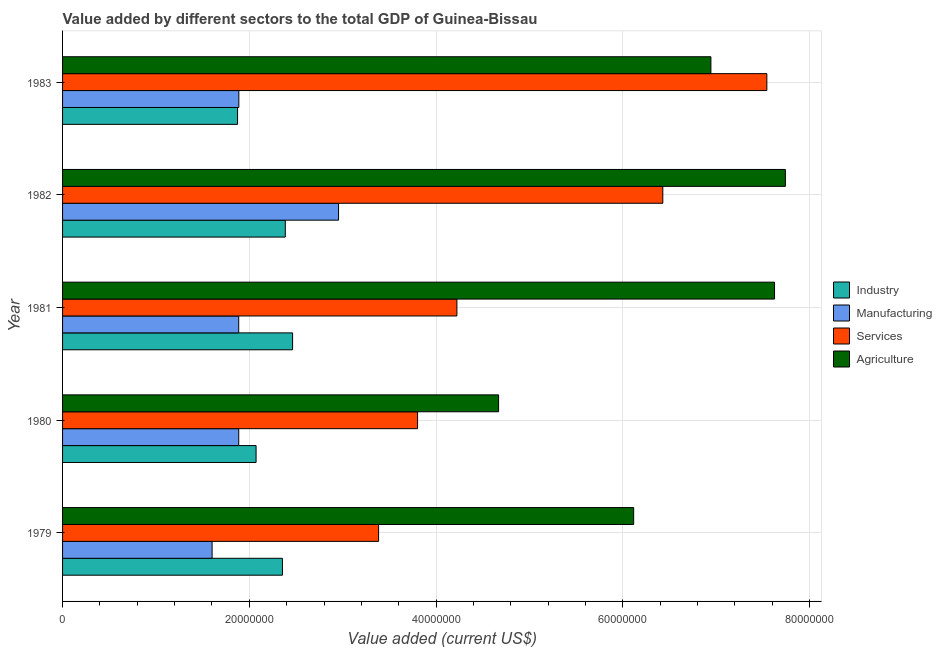How many groups of bars are there?
Your answer should be very brief. 5. Are the number of bars per tick equal to the number of legend labels?
Give a very brief answer. Yes. How many bars are there on the 5th tick from the top?
Your response must be concise. 4. What is the label of the 3rd group of bars from the top?
Your response must be concise. 1981. In how many cases, is the number of bars for a given year not equal to the number of legend labels?
Make the answer very short. 0. What is the value added by manufacturing sector in 1982?
Give a very brief answer. 2.96e+07. Across all years, what is the maximum value added by industrial sector?
Make the answer very short. 2.46e+07. Across all years, what is the minimum value added by services sector?
Provide a succinct answer. 3.38e+07. What is the total value added by services sector in the graph?
Keep it short and to the point. 2.54e+08. What is the difference between the value added by industrial sector in 1982 and that in 1983?
Keep it short and to the point. 5.11e+06. What is the difference between the value added by industrial sector in 1979 and the value added by services sector in 1983?
Your answer should be compact. -5.19e+07. What is the average value added by agricultural sector per year?
Give a very brief answer. 6.62e+07. In the year 1982, what is the difference between the value added by manufacturing sector and value added by industrial sector?
Ensure brevity in your answer.  5.70e+06. What is the ratio of the value added by manufacturing sector in 1979 to that in 1982?
Give a very brief answer. 0.54. Is the difference between the value added by services sector in 1980 and 1981 greater than the difference between the value added by industrial sector in 1980 and 1981?
Ensure brevity in your answer.  No. What is the difference between the highest and the second highest value added by agricultural sector?
Offer a terse response. 1.16e+06. What is the difference between the highest and the lowest value added by agricultural sector?
Your answer should be very brief. 3.07e+07. Is it the case that in every year, the sum of the value added by agricultural sector and value added by manufacturing sector is greater than the sum of value added by industrial sector and value added by services sector?
Offer a terse response. Yes. What does the 4th bar from the top in 1980 represents?
Your answer should be compact. Industry. What does the 2nd bar from the bottom in 1982 represents?
Your answer should be very brief. Manufacturing. Is it the case that in every year, the sum of the value added by industrial sector and value added by manufacturing sector is greater than the value added by services sector?
Ensure brevity in your answer.  No. How many bars are there?
Your answer should be compact. 20. Are all the bars in the graph horizontal?
Keep it short and to the point. Yes. How many years are there in the graph?
Provide a short and direct response. 5. What is the difference between two consecutive major ticks on the X-axis?
Keep it short and to the point. 2.00e+07. Does the graph contain grids?
Your answer should be very brief. Yes. How many legend labels are there?
Offer a very short reply. 4. How are the legend labels stacked?
Offer a terse response. Vertical. What is the title of the graph?
Your answer should be compact. Value added by different sectors to the total GDP of Guinea-Bissau. What is the label or title of the X-axis?
Provide a short and direct response. Value added (current US$). What is the label or title of the Y-axis?
Your answer should be compact. Year. What is the Value added (current US$) of Industry in 1979?
Your response must be concise. 2.35e+07. What is the Value added (current US$) in Manufacturing in 1979?
Offer a terse response. 1.60e+07. What is the Value added (current US$) in Services in 1979?
Your response must be concise. 3.38e+07. What is the Value added (current US$) of Agriculture in 1979?
Your answer should be compact. 6.12e+07. What is the Value added (current US$) of Industry in 1980?
Give a very brief answer. 2.07e+07. What is the Value added (current US$) in Manufacturing in 1980?
Provide a short and direct response. 1.89e+07. What is the Value added (current US$) in Services in 1980?
Give a very brief answer. 3.80e+07. What is the Value added (current US$) of Agriculture in 1980?
Make the answer very short. 4.67e+07. What is the Value added (current US$) in Industry in 1981?
Ensure brevity in your answer.  2.46e+07. What is the Value added (current US$) in Manufacturing in 1981?
Your answer should be very brief. 1.89e+07. What is the Value added (current US$) in Services in 1981?
Provide a short and direct response. 4.22e+07. What is the Value added (current US$) in Agriculture in 1981?
Your response must be concise. 7.62e+07. What is the Value added (current US$) of Industry in 1982?
Your answer should be compact. 2.39e+07. What is the Value added (current US$) of Manufacturing in 1982?
Give a very brief answer. 2.96e+07. What is the Value added (current US$) of Services in 1982?
Your answer should be compact. 6.43e+07. What is the Value added (current US$) of Agriculture in 1982?
Offer a very short reply. 7.74e+07. What is the Value added (current US$) in Industry in 1983?
Your answer should be very brief. 1.87e+07. What is the Value added (current US$) in Manufacturing in 1983?
Offer a terse response. 1.89e+07. What is the Value added (current US$) of Services in 1983?
Provide a succinct answer. 7.54e+07. What is the Value added (current US$) of Agriculture in 1983?
Provide a succinct answer. 6.94e+07. Across all years, what is the maximum Value added (current US$) of Industry?
Give a very brief answer. 2.46e+07. Across all years, what is the maximum Value added (current US$) of Manufacturing?
Provide a short and direct response. 2.96e+07. Across all years, what is the maximum Value added (current US$) of Services?
Keep it short and to the point. 7.54e+07. Across all years, what is the maximum Value added (current US$) in Agriculture?
Ensure brevity in your answer.  7.74e+07. Across all years, what is the minimum Value added (current US$) of Industry?
Give a very brief answer. 1.87e+07. Across all years, what is the minimum Value added (current US$) in Manufacturing?
Your answer should be very brief. 1.60e+07. Across all years, what is the minimum Value added (current US$) of Services?
Your response must be concise. 3.38e+07. Across all years, what is the minimum Value added (current US$) in Agriculture?
Give a very brief answer. 4.67e+07. What is the total Value added (current US$) in Industry in the graph?
Give a very brief answer. 1.11e+08. What is the total Value added (current US$) in Manufacturing in the graph?
Ensure brevity in your answer.  1.02e+08. What is the total Value added (current US$) of Services in the graph?
Keep it short and to the point. 2.54e+08. What is the total Value added (current US$) of Agriculture in the graph?
Offer a very short reply. 3.31e+08. What is the difference between the Value added (current US$) of Industry in 1979 and that in 1980?
Provide a succinct answer. 2.82e+06. What is the difference between the Value added (current US$) of Manufacturing in 1979 and that in 1980?
Give a very brief answer. -2.85e+06. What is the difference between the Value added (current US$) in Services in 1979 and that in 1980?
Provide a short and direct response. -4.17e+06. What is the difference between the Value added (current US$) in Agriculture in 1979 and that in 1980?
Make the answer very short. 1.45e+07. What is the difference between the Value added (current US$) of Industry in 1979 and that in 1981?
Keep it short and to the point. -1.09e+06. What is the difference between the Value added (current US$) of Manufacturing in 1979 and that in 1981?
Your answer should be compact. -2.85e+06. What is the difference between the Value added (current US$) in Services in 1979 and that in 1981?
Provide a succinct answer. -8.39e+06. What is the difference between the Value added (current US$) of Agriculture in 1979 and that in 1981?
Make the answer very short. -1.51e+07. What is the difference between the Value added (current US$) of Industry in 1979 and that in 1982?
Offer a terse response. -3.05e+05. What is the difference between the Value added (current US$) of Manufacturing in 1979 and that in 1982?
Your answer should be compact. -1.35e+07. What is the difference between the Value added (current US$) in Services in 1979 and that in 1982?
Offer a very short reply. -3.04e+07. What is the difference between the Value added (current US$) of Agriculture in 1979 and that in 1982?
Your answer should be compact. -1.62e+07. What is the difference between the Value added (current US$) in Industry in 1979 and that in 1983?
Provide a succinct answer. 4.81e+06. What is the difference between the Value added (current US$) of Manufacturing in 1979 and that in 1983?
Give a very brief answer. -2.86e+06. What is the difference between the Value added (current US$) in Services in 1979 and that in 1983?
Your response must be concise. -4.16e+07. What is the difference between the Value added (current US$) of Agriculture in 1979 and that in 1983?
Make the answer very short. -8.27e+06. What is the difference between the Value added (current US$) in Industry in 1980 and that in 1981?
Keep it short and to the point. -3.91e+06. What is the difference between the Value added (current US$) of Manufacturing in 1980 and that in 1981?
Provide a short and direct response. 1069.58. What is the difference between the Value added (current US$) in Services in 1980 and that in 1981?
Make the answer very short. -4.21e+06. What is the difference between the Value added (current US$) of Agriculture in 1980 and that in 1981?
Keep it short and to the point. -2.95e+07. What is the difference between the Value added (current US$) of Industry in 1980 and that in 1982?
Ensure brevity in your answer.  -3.13e+06. What is the difference between the Value added (current US$) of Manufacturing in 1980 and that in 1982?
Provide a succinct answer. -1.07e+07. What is the difference between the Value added (current US$) of Services in 1980 and that in 1982?
Provide a short and direct response. -2.63e+07. What is the difference between the Value added (current US$) of Agriculture in 1980 and that in 1982?
Offer a very short reply. -3.07e+07. What is the difference between the Value added (current US$) in Industry in 1980 and that in 1983?
Provide a short and direct response. 1.98e+06. What is the difference between the Value added (current US$) of Manufacturing in 1980 and that in 1983?
Your response must be concise. -1.22e+04. What is the difference between the Value added (current US$) in Services in 1980 and that in 1983?
Your answer should be compact. -3.74e+07. What is the difference between the Value added (current US$) in Agriculture in 1980 and that in 1983?
Keep it short and to the point. -2.27e+07. What is the difference between the Value added (current US$) of Industry in 1981 and that in 1982?
Your answer should be compact. 7.82e+05. What is the difference between the Value added (current US$) of Manufacturing in 1981 and that in 1982?
Give a very brief answer. -1.07e+07. What is the difference between the Value added (current US$) of Services in 1981 and that in 1982?
Your answer should be compact. -2.20e+07. What is the difference between the Value added (current US$) in Agriculture in 1981 and that in 1982?
Provide a short and direct response. -1.16e+06. What is the difference between the Value added (current US$) in Industry in 1981 and that in 1983?
Keep it short and to the point. 5.89e+06. What is the difference between the Value added (current US$) in Manufacturing in 1981 and that in 1983?
Offer a very short reply. -1.33e+04. What is the difference between the Value added (current US$) of Services in 1981 and that in 1983?
Provide a short and direct response. -3.32e+07. What is the difference between the Value added (current US$) of Agriculture in 1981 and that in 1983?
Make the answer very short. 6.81e+06. What is the difference between the Value added (current US$) of Industry in 1982 and that in 1983?
Keep it short and to the point. 5.11e+06. What is the difference between the Value added (current US$) of Manufacturing in 1982 and that in 1983?
Offer a terse response. 1.07e+07. What is the difference between the Value added (current US$) of Services in 1982 and that in 1983?
Your answer should be very brief. -1.11e+07. What is the difference between the Value added (current US$) in Agriculture in 1982 and that in 1983?
Provide a succinct answer. 7.97e+06. What is the difference between the Value added (current US$) in Industry in 1979 and the Value added (current US$) in Manufacturing in 1980?
Provide a short and direct response. 4.68e+06. What is the difference between the Value added (current US$) in Industry in 1979 and the Value added (current US$) in Services in 1980?
Provide a succinct answer. -1.45e+07. What is the difference between the Value added (current US$) of Industry in 1979 and the Value added (current US$) of Agriculture in 1980?
Your answer should be very brief. -2.31e+07. What is the difference between the Value added (current US$) in Manufacturing in 1979 and the Value added (current US$) in Services in 1980?
Your answer should be compact. -2.20e+07. What is the difference between the Value added (current US$) of Manufacturing in 1979 and the Value added (current US$) of Agriculture in 1980?
Your answer should be compact. -3.07e+07. What is the difference between the Value added (current US$) in Services in 1979 and the Value added (current US$) in Agriculture in 1980?
Provide a succinct answer. -1.28e+07. What is the difference between the Value added (current US$) of Industry in 1979 and the Value added (current US$) of Manufacturing in 1981?
Make the answer very short. 4.68e+06. What is the difference between the Value added (current US$) in Industry in 1979 and the Value added (current US$) in Services in 1981?
Ensure brevity in your answer.  -1.87e+07. What is the difference between the Value added (current US$) of Industry in 1979 and the Value added (current US$) of Agriculture in 1981?
Provide a succinct answer. -5.27e+07. What is the difference between the Value added (current US$) of Manufacturing in 1979 and the Value added (current US$) of Services in 1981?
Your response must be concise. -2.62e+07. What is the difference between the Value added (current US$) of Manufacturing in 1979 and the Value added (current US$) of Agriculture in 1981?
Provide a short and direct response. -6.02e+07. What is the difference between the Value added (current US$) of Services in 1979 and the Value added (current US$) of Agriculture in 1981?
Ensure brevity in your answer.  -4.24e+07. What is the difference between the Value added (current US$) in Industry in 1979 and the Value added (current US$) in Manufacturing in 1982?
Your answer should be very brief. -6.01e+06. What is the difference between the Value added (current US$) in Industry in 1979 and the Value added (current US$) in Services in 1982?
Give a very brief answer. -4.07e+07. What is the difference between the Value added (current US$) in Industry in 1979 and the Value added (current US$) in Agriculture in 1982?
Provide a short and direct response. -5.39e+07. What is the difference between the Value added (current US$) of Manufacturing in 1979 and the Value added (current US$) of Services in 1982?
Provide a succinct answer. -4.83e+07. What is the difference between the Value added (current US$) of Manufacturing in 1979 and the Value added (current US$) of Agriculture in 1982?
Your answer should be compact. -6.14e+07. What is the difference between the Value added (current US$) in Services in 1979 and the Value added (current US$) in Agriculture in 1982?
Make the answer very short. -4.36e+07. What is the difference between the Value added (current US$) in Industry in 1979 and the Value added (current US$) in Manufacturing in 1983?
Offer a terse response. 4.67e+06. What is the difference between the Value added (current US$) of Industry in 1979 and the Value added (current US$) of Services in 1983?
Offer a terse response. -5.19e+07. What is the difference between the Value added (current US$) in Industry in 1979 and the Value added (current US$) in Agriculture in 1983?
Your response must be concise. -4.59e+07. What is the difference between the Value added (current US$) of Manufacturing in 1979 and the Value added (current US$) of Services in 1983?
Keep it short and to the point. -5.94e+07. What is the difference between the Value added (current US$) in Manufacturing in 1979 and the Value added (current US$) in Agriculture in 1983?
Your answer should be very brief. -5.34e+07. What is the difference between the Value added (current US$) of Services in 1979 and the Value added (current US$) of Agriculture in 1983?
Provide a short and direct response. -3.56e+07. What is the difference between the Value added (current US$) in Industry in 1980 and the Value added (current US$) in Manufacturing in 1981?
Offer a very short reply. 1.86e+06. What is the difference between the Value added (current US$) of Industry in 1980 and the Value added (current US$) of Services in 1981?
Your response must be concise. -2.15e+07. What is the difference between the Value added (current US$) in Industry in 1980 and the Value added (current US$) in Agriculture in 1981?
Provide a succinct answer. -5.55e+07. What is the difference between the Value added (current US$) of Manufacturing in 1980 and the Value added (current US$) of Services in 1981?
Offer a very short reply. -2.34e+07. What is the difference between the Value added (current US$) of Manufacturing in 1980 and the Value added (current US$) of Agriculture in 1981?
Give a very brief answer. -5.74e+07. What is the difference between the Value added (current US$) of Services in 1980 and the Value added (current US$) of Agriculture in 1981?
Your answer should be very brief. -3.82e+07. What is the difference between the Value added (current US$) of Industry in 1980 and the Value added (current US$) of Manufacturing in 1982?
Keep it short and to the point. -8.83e+06. What is the difference between the Value added (current US$) of Industry in 1980 and the Value added (current US$) of Services in 1982?
Your answer should be compact. -4.36e+07. What is the difference between the Value added (current US$) in Industry in 1980 and the Value added (current US$) in Agriculture in 1982?
Provide a short and direct response. -5.67e+07. What is the difference between the Value added (current US$) of Manufacturing in 1980 and the Value added (current US$) of Services in 1982?
Ensure brevity in your answer.  -4.54e+07. What is the difference between the Value added (current US$) in Manufacturing in 1980 and the Value added (current US$) in Agriculture in 1982?
Give a very brief answer. -5.85e+07. What is the difference between the Value added (current US$) in Services in 1980 and the Value added (current US$) in Agriculture in 1982?
Offer a very short reply. -3.94e+07. What is the difference between the Value added (current US$) in Industry in 1980 and the Value added (current US$) in Manufacturing in 1983?
Give a very brief answer. 1.85e+06. What is the difference between the Value added (current US$) in Industry in 1980 and the Value added (current US$) in Services in 1983?
Provide a short and direct response. -5.47e+07. What is the difference between the Value added (current US$) in Industry in 1980 and the Value added (current US$) in Agriculture in 1983?
Keep it short and to the point. -4.87e+07. What is the difference between the Value added (current US$) of Manufacturing in 1980 and the Value added (current US$) of Services in 1983?
Provide a succinct answer. -5.66e+07. What is the difference between the Value added (current US$) of Manufacturing in 1980 and the Value added (current US$) of Agriculture in 1983?
Your answer should be very brief. -5.06e+07. What is the difference between the Value added (current US$) of Services in 1980 and the Value added (current US$) of Agriculture in 1983?
Your response must be concise. -3.14e+07. What is the difference between the Value added (current US$) in Industry in 1981 and the Value added (current US$) in Manufacturing in 1982?
Your answer should be compact. -4.92e+06. What is the difference between the Value added (current US$) of Industry in 1981 and the Value added (current US$) of Services in 1982?
Provide a short and direct response. -3.96e+07. What is the difference between the Value added (current US$) in Industry in 1981 and the Value added (current US$) in Agriculture in 1982?
Provide a succinct answer. -5.28e+07. What is the difference between the Value added (current US$) in Manufacturing in 1981 and the Value added (current US$) in Services in 1982?
Ensure brevity in your answer.  -4.54e+07. What is the difference between the Value added (current US$) of Manufacturing in 1981 and the Value added (current US$) of Agriculture in 1982?
Ensure brevity in your answer.  -5.85e+07. What is the difference between the Value added (current US$) in Services in 1981 and the Value added (current US$) in Agriculture in 1982?
Your answer should be compact. -3.52e+07. What is the difference between the Value added (current US$) in Industry in 1981 and the Value added (current US$) in Manufacturing in 1983?
Your response must be concise. 5.76e+06. What is the difference between the Value added (current US$) of Industry in 1981 and the Value added (current US$) of Services in 1983?
Keep it short and to the point. -5.08e+07. What is the difference between the Value added (current US$) in Industry in 1981 and the Value added (current US$) in Agriculture in 1983?
Offer a terse response. -4.48e+07. What is the difference between the Value added (current US$) of Manufacturing in 1981 and the Value added (current US$) of Services in 1983?
Offer a very short reply. -5.66e+07. What is the difference between the Value added (current US$) in Manufacturing in 1981 and the Value added (current US$) in Agriculture in 1983?
Your response must be concise. -5.06e+07. What is the difference between the Value added (current US$) of Services in 1981 and the Value added (current US$) of Agriculture in 1983?
Your answer should be compact. -2.72e+07. What is the difference between the Value added (current US$) in Industry in 1982 and the Value added (current US$) in Manufacturing in 1983?
Ensure brevity in your answer.  4.97e+06. What is the difference between the Value added (current US$) of Industry in 1982 and the Value added (current US$) of Services in 1983?
Ensure brevity in your answer.  -5.16e+07. What is the difference between the Value added (current US$) in Industry in 1982 and the Value added (current US$) in Agriculture in 1983?
Keep it short and to the point. -4.56e+07. What is the difference between the Value added (current US$) in Manufacturing in 1982 and the Value added (current US$) in Services in 1983?
Offer a very short reply. -4.59e+07. What is the difference between the Value added (current US$) of Manufacturing in 1982 and the Value added (current US$) of Agriculture in 1983?
Offer a very short reply. -3.99e+07. What is the difference between the Value added (current US$) in Services in 1982 and the Value added (current US$) in Agriculture in 1983?
Keep it short and to the point. -5.15e+06. What is the average Value added (current US$) of Industry per year?
Keep it short and to the point. 2.23e+07. What is the average Value added (current US$) in Manufacturing per year?
Your answer should be compact. 2.04e+07. What is the average Value added (current US$) in Services per year?
Give a very brief answer. 5.08e+07. What is the average Value added (current US$) in Agriculture per year?
Ensure brevity in your answer.  6.62e+07. In the year 1979, what is the difference between the Value added (current US$) of Industry and Value added (current US$) of Manufacturing?
Your response must be concise. 7.53e+06. In the year 1979, what is the difference between the Value added (current US$) of Industry and Value added (current US$) of Services?
Provide a succinct answer. -1.03e+07. In the year 1979, what is the difference between the Value added (current US$) in Industry and Value added (current US$) in Agriculture?
Offer a very short reply. -3.76e+07. In the year 1979, what is the difference between the Value added (current US$) of Manufacturing and Value added (current US$) of Services?
Provide a succinct answer. -1.78e+07. In the year 1979, what is the difference between the Value added (current US$) in Manufacturing and Value added (current US$) in Agriculture?
Keep it short and to the point. -4.51e+07. In the year 1979, what is the difference between the Value added (current US$) in Services and Value added (current US$) in Agriculture?
Give a very brief answer. -2.73e+07. In the year 1980, what is the difference between the Value added (current US$) of Industry and Value added (current US$) of Manufacturing?
Ensure brevity in your answer.  1.86e+06. In the year 1980, what is the difference between the Value added (current US$) in Industry and Value added (current US$) in Services?
Your answer should be compact. -1.73e+07. In the year 1980, what is the difference between the Value added (current US$) of Industry and Value added (current US$) of Agriculture?
Ensure brevity in your answer.  -2.60e+07. In the year 1980, what is the difference between the Value added (current US$) in Manufacturing and Value added (current US$) in Services?
Make the answer very short. -1.92e+07. In the year 1980, what is the difference between the Value added (current US$) in Manufacturing and Value added (current US$) in Agriculture?
Keep it short and to the point. -2.78e+07. In the year 1980, what is the difference between the Value added (current US$) of Services and Value added (current US$) of Agriculture?
Offer a terse response. -8.68e+06. In the year 1981, what is the difference between the Value added (current US$) in Industry and Value added (current US$) in Manufacturing?
Keep it short and to the point. 5.77e+06. In the year 1981, what is the difference between the Value added (current US$) in Industry and Value added (current US$) in Services?
Give a very brief answer. -1.76e+07. In the year 1981, what is the difference between the Value added (current US$) in Industry and Value added (current US$) in Agriculture?
Your answer should be compact. -5.16e+07. In the year 1981, what is the difference between the Value added (current US$) in Manufacturing and Value added (current US$) in Services?
Ensure brevity in your answer.  -2.34e+07. In the year 1981, what is the difference between the Value added (current US$) in Manufacturing and Value added (current US$) in Agriculture?
Provide a short and direct response. -5.74e+07. In the year 1981, what is the difference between the Value added (current US$) in Services and Value added (current US$) in Agriculture?
Your answer should be compact. -3.40e+07. In the year 1982, what is the difference between the Value added (current US$) in Industry and Value added (current US$) in Manufacturing?
Your answer should be very brief. -5.70e+06. In the year 1982, what is the difference between the Value added (current US$) of Industry and Value added (current US$) of Services?
Ensure brevity in your answer.  -4.04e+07. In the year 1982, what is the difference between the Value added (current US$) of Industry and Value added (current US$) of Agriculture?
Ensure brevity in your answer.  -5.35e+07. In the year 1982, what is the difference between the Value added (current US$) in Manufacturing and Value added (current US$) in Services?
Your answer should be very brief. -3.47e+07. In the year 1982, what is the difference between the Value added (current US$) of Manufacturing and Value added (current US$) of Agriculture?
Offer a terse response. -4.78e+07. In the year 1982, what is the difference between the Value added (current US$) of Services and Value added (current US$) of Agriculture?
Ensure brevity in your answer.  -1.31e+07. In the year 1983, what is the difference between the Value added (current US$) of Industry and Value added (current US$) of Manufacturing?
Provide a succinct answer. -1.37e+05. In the year 1983, what is the difference between the Value added (current US$) of Industry and Value added (current US$) of Services?
Give a very brief answer. -5.67e+07. In the year 1983, what is the difference between the Value added (current US$) of Industry and Value added (current US$) of Agriculture?
Keep it short and to the point. -5.07e+07. In the year 1983, what is the difference between the Value added (current US$) in Manufacturing and Value added (current US$) in Services?
Keep it short and to the point. -5.65e+07. In the year 1983, what is the difference between the Value added (current US$) of Manufacturing and Value added (current US$) of Agriculture?
Your answer should be very brief. -5.05e+07. In the year 1983, what is the difference between the Value added (current US$) in Services and Value added (current US$) in Agriculture?
Provide a short and direct response. 5.99e+06. What is the ratio of the Value added (current US$) in Industry in 1979 to that in 1980?
Ensure brevity in your answer.  1.14. What is the ratio of the Value added (current US$) in Manufacturing in 1979 to that in 1980?
Offer a very short reply. 0.85. What is the ratio of the Value added (current US$) of Services in 1979 to that in 1980?
Your answer should be very brief. 0.89. What is the ratio of the Value added (current US$) of Agriculture in 1979 to that in 1980?
Offer a very short reply. 1.31. What is the ratio of the Value added (current US$) in Industry in 1979 to that in 1981?
Provide a short and direct response. 0.96. What is the ratio of the Value added (current US$) in Manufacturing in 1979 to that in 1981?
Make the answer very short. 0.85. What is the ratio of the Value added (current US$) of Services in 1979 to that in 1981?
Provide a succinct answer. 0.8. What is the ratio of the Value added (current US$) of Agriculture in 1979 to that in 1981?
Ensure brevity in your answer.  0.8. What is the ratio of the Value added (current US$) in Industry in 1979 to that in 1982?
Your response must be concise. 0.99. What is the ratio of the Value added (current US$) in Manufacturing in 1979 to that in 1982?
Your answer should be compact. 0.54. What is the ratio of the Value added (current US$) in Services in 1979 to that in 1982?
Give a very brief answer. 0.53. What is the ratio of the Value added (current US$) of Agriculture in 1979 to that in 1982?
Offer a very short reply. 0.79. What is the ratio of the Value added (current US$) of Industry in 1979 to that in 1983?
Your answer should be very brief. 1.26. What is the ratio of the Value added (current US$) of Manufacturing in 1979 to that in 1983?
Your response must be concise. 0.85. What is the ratio of the Value added (current US$) in Services in 1979 to that in 1983?
Offer a very short reply. 0.45. What is the ratio of the Value added (current US$) in Agriculture in 1979 to that in 1983?
Provide a succinct answer. 0.88. What is the ratio of the Value added (current US$) of Industry in 1980 to that in 1981?
Your answer should be very brief. 0.84. What is the ratio of the Value added (current US$) of Manufacturing in 1980 to that in 1981?
Keep it short and to the point. 1. What is the ratio of the Value added (current US$) of Services in 1980 to that in 1981?
Your answer should be compact. 0.9. What is the ratio of the Value added (current US$) in Agriculture in 1980 to that in 1981?
Give a very brief answer. 0.61. What is the ratio of the Value added (current US$) of Industry in 1980 to that in 1982?
Your answer should be compact. 0.87. What is the ratio of the Value added (current US$) of Manufacturing in 1980 to that in 1982?
Provide a succinct answer. 0.64. What is the ratio of the Value added (current US$) in Services in 1980 to that in 1982?
Make the answer very short. 0.59. What is the ratio of the Value added (current US$) of Agriculture in 1980 to that in 1982?
Make the answer very short. 0.6. What is the ratio of the Value added (current US$) in Industry in 1980 to that in 1983?
Give a very brief answer. 1.11. What is the ratio of the Value added (current US$) in Manufacturing in 1980 to that in 1983?
Your response must be concise. 1. What is the ratio of the Value added (current US$) of Services in 1980 to that in 1983?
Offer a terse response. 0.5. What is the ratio of the Value added (current US$) in Agriculture in 1980 to that in 1983?
Ensure brevity in your answer.  0.67. What is the ratio of the Value added (current US$) of Industry in 1981 to that in 1982?
Your response must be concise. 1.03. What is the ratio of the Value added (current US$) of Manufacturing in 1981 to that in 1982?
Your response must be concise. 0.64. What is the ratio of the Value added (current US$) of Services in 1981 to that in 1982?
Make the answer very short. 0.66. What is the ratio of the Value added (current US$) of Industry in 1981 to that in 1983?
Ensure brevity in your answer.  1.31. What is the ratio of the Value added (current US$) of Manufacturing in 1981 to that in 1983?
Your answer should be compact. 1. What is the ratio of the Value added (current US$) of Services in 1981 to that in 1983?
Offer a very short reply. 0.56. What is the ratio of the Value added (current US$) in Agriculture in 1981 to that in 1983?
Offer a terse response. 1.1. What is the ratio of the Value added (current US$) in Industry in 1982 to that in 1983?
Your answer should be very brief. 1.27. What is the ratio of the Value added (current US$) of Manufacturing in 1982 to that in 1983?
Provide a short and direct response. 1.57. What is the ratio of the Value added (current US$) in Services in 1982 to that in 1983?
Your answer should be compact. 0.85. What is the ratio of the Value added (current US$) in Agriculture in 1982 to that in 1983?
Keep it short and to the point. 1.11. What is the difference between the highest and the second highest Value added (current US$) of Industry?
Make the answer very short. 7.82e+05. What is the difference between the highest and the second highest Value added (current US$) in Manufacturing?
Your answer should be compact. 1.07e+07. What is the difference between the highest and the second highest Value added (current US$) of Services?
Provide a short and direct response. 1.11e+07. What is the difference between the highest and the second highest Value added (current US$) of Agriculture?
Provide a succinct answer. 1.16e+06. What is the difference between the highest and the lowest Value added (current US$) of Industry?
Offer a very short reply. 5.89e+06. What is the difference between the highest and the lowest Value added (current US$) in Manufacturing?
Make the answer very short. 1.35e+07. What is the difference between the highest and the lowest Value added (current US$) in Services?
Provide a short and direct response. 4.16e+07. What is the difference between the highest and the lowest Value added (current US$) in Agriculture?
Offer a terse response. 3.07e+07. 